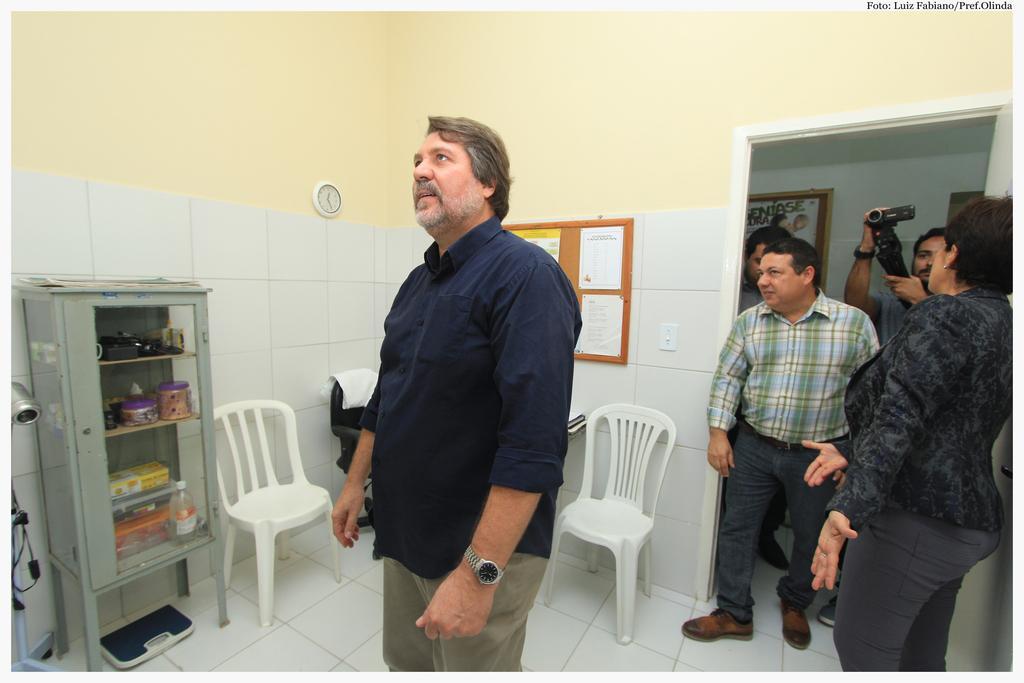Please provide a concise description of this image. A man is standing and looking at something in a room. There are few men and a woman standing at the door. There are few chairs and a cupboard with some items. 